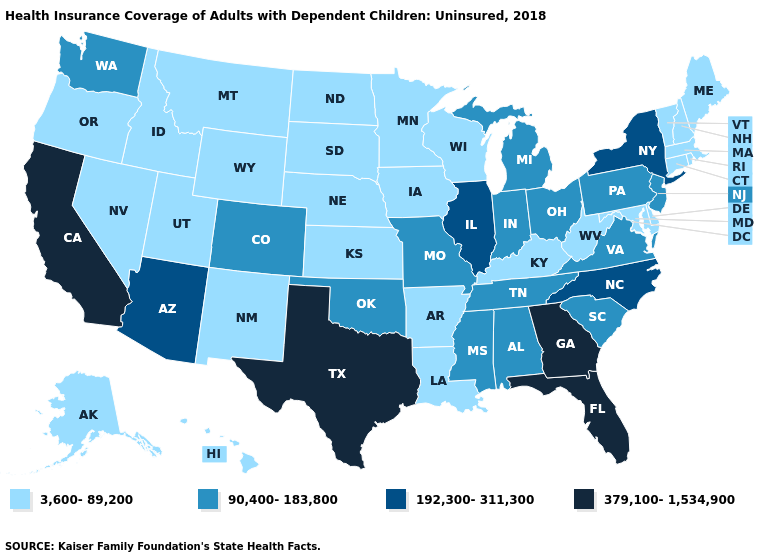Among the states that border West Virginia , does Kentucky have the highest value?
Short answer required. No. Does Hawaii have a lower value than Louisiana?
Be succinct. No. What is the value of Idaho?
Concise answer only. 3,600-89,200. Does Wisconsin have the highest value in the USA?
Concise answer only. No. What is the value of New Hampshire?
Answer briefly. 3,600-89,200. Name the states that have a value in the range 379,100-1,534,900?
Give a very brief answer. California, Florida, Georgia, Texas. Which states hav the highest value in the West?
Be succinct. California. Does the map have missing data?
Quick response, please. No. Among the states that border Mississippi , does Louisiana have the highest value?
Concise answer only. No. Among the states that border Missouri , which have the lowest value?
Short answer required. Arkansas, Iowa, Kansas, Kentucky, Nebraska. Which states hav the highest value in the MidWest?
Answer briefly. Illinois. What is the value of New York?
Write a very short answer. 192,300-311,300. Does North Carolina have the same value as Mississippi?
Be succinct. No. What is the value of Kansas?
Quick response, please. 3,600-89,200. 